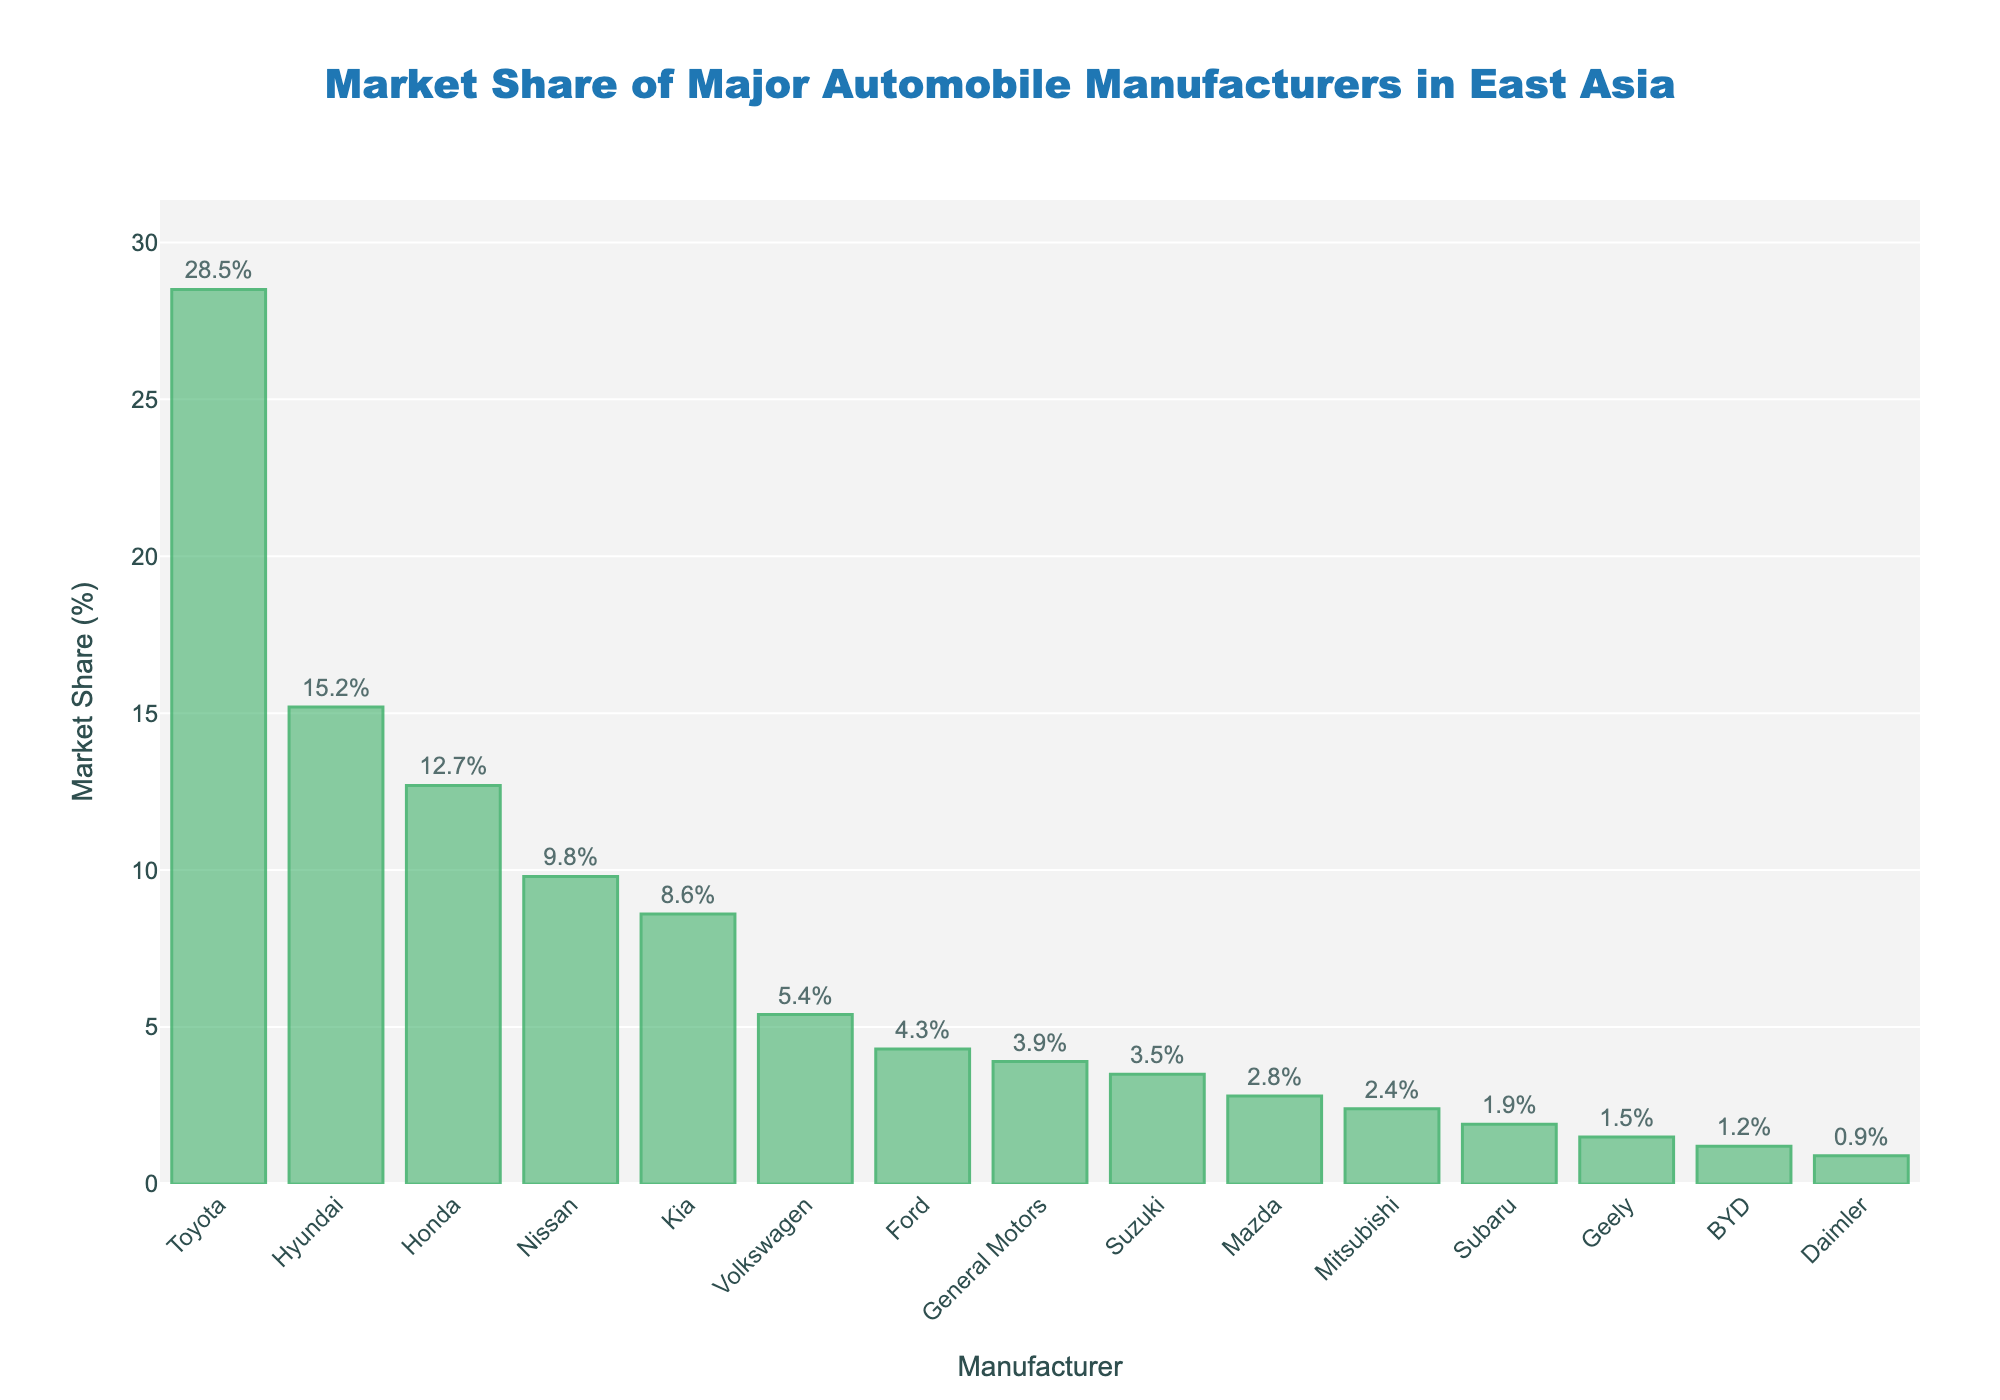Which manufacturer has the highest market share? The manufacturer with the tallest bar has the highest market share. The tallest bar corresponds to Toyota.
Answer: Toyota What is the combined market share of Hyundai and Kia? Add the market shares of Hyundai and Kia. Hyundai has 15.2% and Kia has 8.6%. 15.2 + 8.6 = 23.8.
Answer: 23.8% How does Honda's market share compare to Nissan's? Compare the heights of the bars representing Honda and Nissan. Honda’s market share is 12.7%, and Nissan’s is 9.8%. Honda’s market share is higher.
Answer: Honda > Nissan Which manufacturer has the smallest market share, and what is its value? The manufacturer with the shortest bar has the smallest market share. The shortest bar corresponds to Daimler with a market share of 0.9%.
Answer: Daimler, 0.9% What is the market share difference between Toyota and Hyundai? Subtract Hyundai's market share from Toyota's. Toyota has 28.5%, and Hyundai has 15.2%. 28.5 - 15.2 = 13.3.
Answer: 13.3% What is the average market share of Volkswagen, Ford, and General Motors? Calculate the average by summing their market shares and then dividing by the number of manufacturers. (5.4 + 4.3 + 3.9) / 3 = 13.6 / 3 = 4.53.
Answer: 4.53% How does Geely's market share compare to BYD's? Compare the heights of the bars representing Geely and BYD. Geely has a market share of 1.5%, and BYD has 1.2%. Geely’s market share is higher.
Answer: Geely > BYD Which manufacturers have market shares greater than 5% but less than 10%? Identify the bars whose heights correspond to market shares in this range. Hyundai (15.2%), Honda (12.7%), and Nissan (9.8%) are out of range. Volkswagen (5.4%) fits.
Answer: Volkswagen What is the total market share of manufacturers with less than 2%? Sum the market shares of Mitsubishi, Subaru, Geely, BYD, and Daimler. 2.4 + 1.9 + 1.5 + 1.2 + 0.9 = 7.9%.
Answer: 7.9% What is the visual cue used to differentiate the bars in the chart? The bars have a specific color with varying height representing market share percentages. The bars are greenish with an outer dark green line, and the height indicates the market share.
Answer: Green color and height 